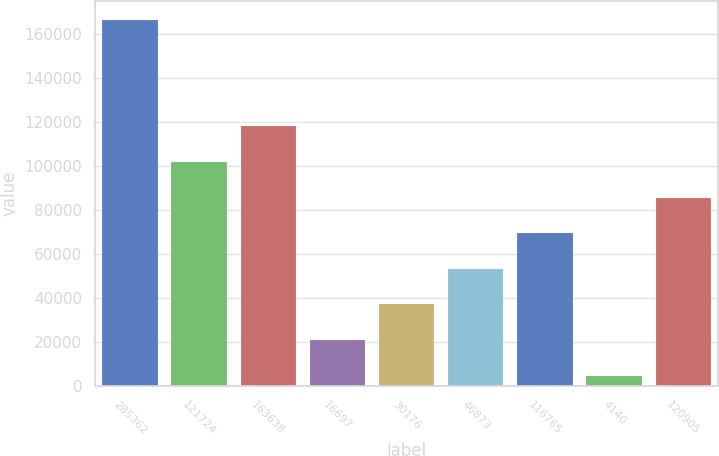Convert chart to OTSL. <chart><loc_0><loc_0><loc_500><loc_500><bar_chart><fcel>285362<fcel>121724<fcel>163638<fcel>16697<fcel>30176<fcel>46873<fcel>116765<fcel>4140<fcel>120905<nl><fcel>166639<fcel>101809<fcel>118016<fcel>20770.6<fcel>36978.2<fcel>53185.8<fcel>69393.4<fcel>4563<fcel>85601<nl></chart> 